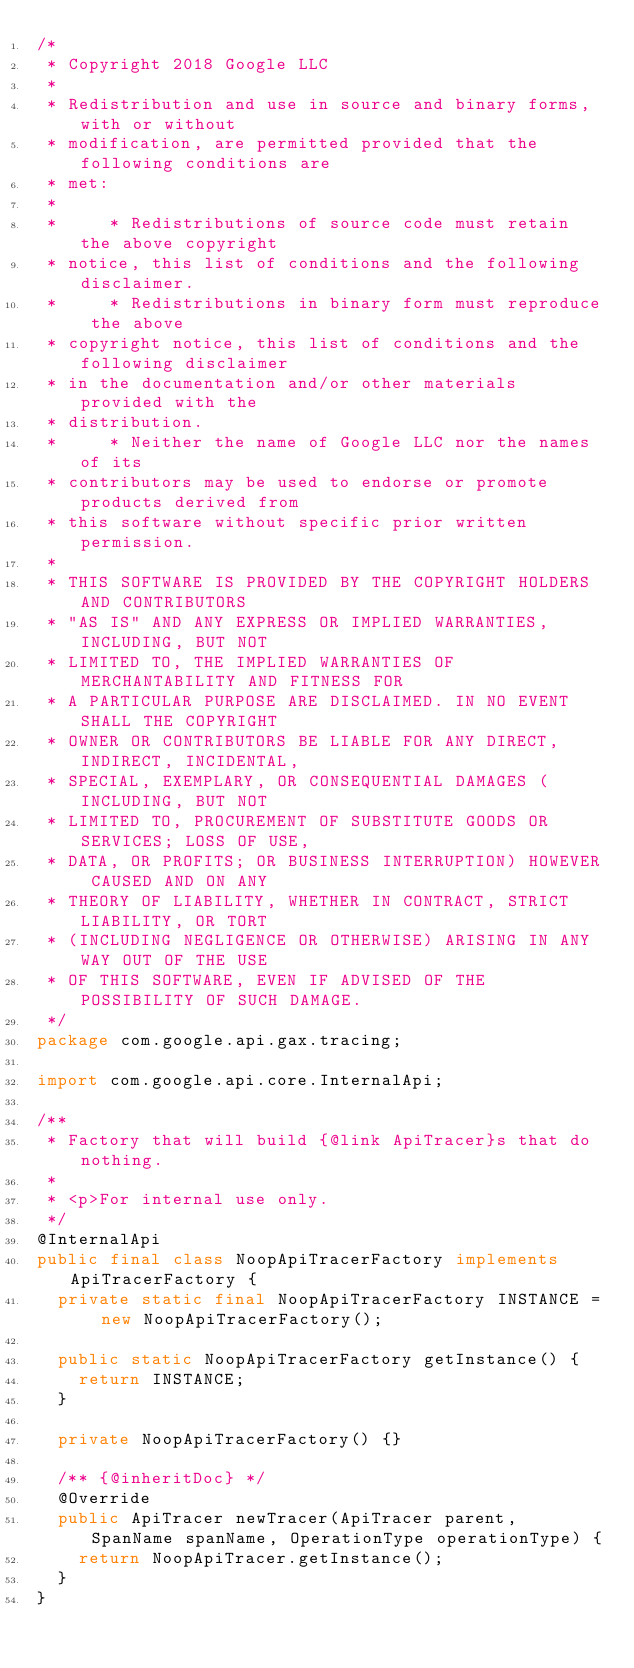<code> <loc_0><loc_0><loc_500><loc_500><_Java_>/*
 * Copyright 2018 Google LLC
 *
 * Redistribution and use in source and binary forms, with or without
 * modification, are permitted provided that the following conditions are
 * met:
 *
 *     * Redistributions of source code must retain the above copyright
 * notice, this list of conditions and the following disclaimer.
 *     * Redistributions in binary form must reproduce the above
 * copyright notice, this list of conditions and the following disclaimer
 * in the documentation and/or other materials provided with the
 * distribution.
 *     * Neither the name of Google LLC nor the names of its
 * contributors may be used to endorse or promote products derived from
 * this software without specific prior written permission.
 *
 * THIS SOFTWARE IS PROVIDED BY THE COPYRIGHT HOLDERS AND CONTRIBUTORS
 * "AS IS" AND ANY EXPRESS OR IMPLIED WARRANTIES, INCLUDING, BUT NOT
 * LIMITED TO, THE IMPLIED WARRANTIES OF MERCHANTABILITY AND FITNESS FOR
 * A PARTICULAR PURPOSE ARE DISCLAIMED. IN NO EVENT SHALL THE COPYRIGHT
 * OWNER OR CONTRIBUTORS BE LIABLE FOR ANY DIRECT, INDIRECT, INCIDENTAL,
 * SPECIAL, EXEMPLARY, OR CONSEQUENTIAL DAMAGES (INCLUDING, BUT NOT
 * LIMITED TO, PROCUREMENT OF SUBSTITUTE GOODS OR SERVICES; LOSS OF USE,
 * DATA, OR PROFITS; OR BUSINESS INTERRUPTION) HOWEVER CAUSED AND ON ANY
 * THEORY OF LIABILITY, WHETHER IN CONTRACT, STRICT LIABILITY, OR TORT
 * (INCLUDING NEGLIGENCE OR OTHERWISE) ARISING IN ANY WAY OUT OF THE USE
 * OF THIS SOFTWARE, EVEN IF ADVISED OF THE POSSIBILITY OF SUCH DAMAGE.
 */
package com.google.api.gax.tracing;

import com.google.api.core.InternalApi;

/**
 * Factory that will build {@link ApiTracer}s that do nothing.
 *
 * <p>For internal use only.
 */
@InternalApi
public final class NoopApiTracerFactory implements ApiTracerFactory {
  private static final NoopApiTracerFactory INSTANCE = new NoopApiTracerFactory();

  public static NoopApiTracerFactory getInstance() {
    return INSTANCE;
  }

  private NoopApiTracerFactory() {}

  /** {@inheritDoc} */
  @Override
  public ApiTracer newTracer(ApiTracer parent, SpanName spanName, OperationType operationType) {
    return NoopApiTracer.getInstance();
  }
}
</code> 